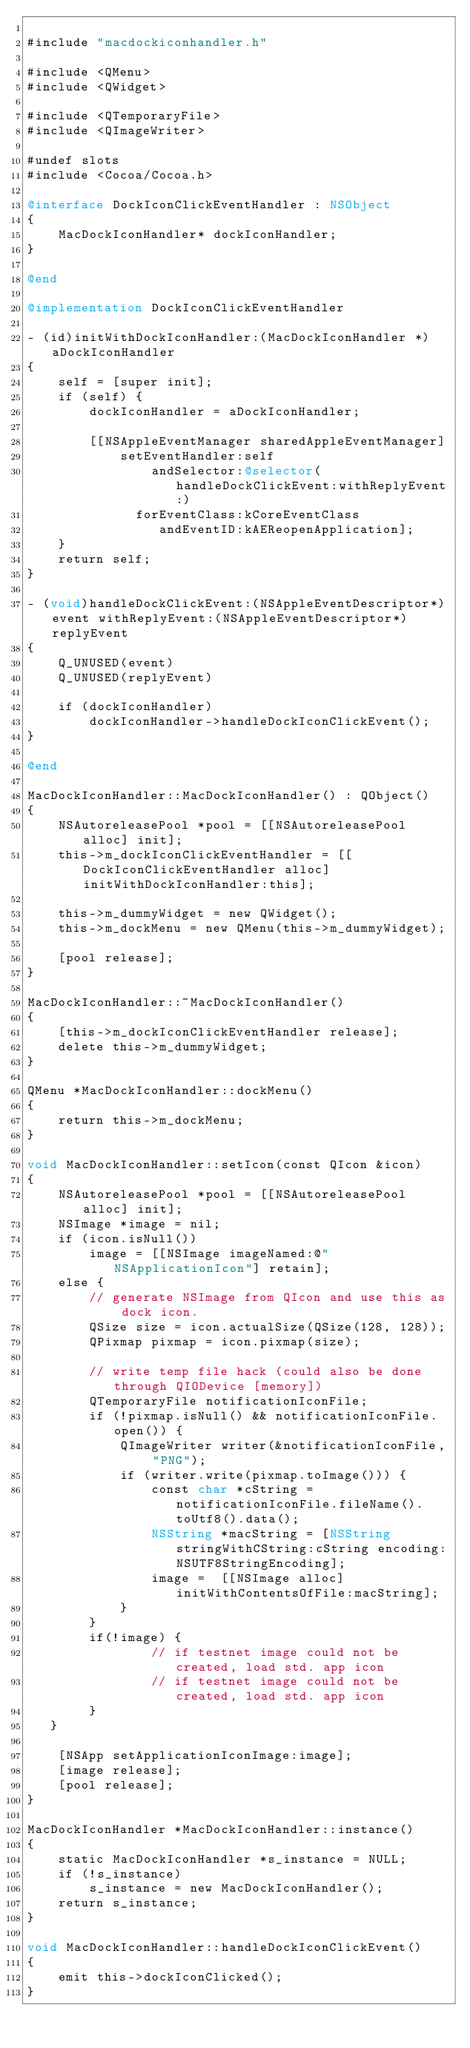Convert code to text. <code><loc_0><loc_0><loc_500><loc_500><_ObjectiveC_>
#include "macdockiconhandler.h"

#include <QMenu>
#include <QWidget>

#include <QTemporaryFile>
#include <QImageWriter>

#undef slots
#include <Cocoa/Cocoa.h>

@interface DockIconClickEventHandler : NSObject
{
    MacDockIconHandler* dockIconHandler;
}

@end

@implementation DockIconClickEventHandler

- (id)initWithDockIconHandler:(MacDockIconHandler *)aDockIconHandler
{
    self = [super init];
    if (self) {
        dockIconHandler = aDockIconHandler;

        [[NSAppleEventManager sharedAppleEventManager]
            setEventHandler:self
                andSelector:@selector(handleDockClickEvent:withReplyEvent:)
              forEventClass:kCoreEventClass
                 andEventID:kAEReopenApplication];
    }
    return self;
}

- (void)handleDockClickEvent:(NSAppleEventDescriptor*)event withReplyEvent:(NSAppleEventDescriptor*)replyEvent
{
    Q_UNUSED(event)
    Q_UNUSED(replyEvent)

    if (dockIconHandler)
        dockIconHandler->handleDockIconClickEvent();
}

@end

MacDockIconHandler::MacDockIconHandler() : QObject()
{
    NSAutoreleasePool *pool = [[NSAutoreleasePool alloc] init];
    this->m_dockIconClickEventHandler = [[DockIconClickEventHandler alloc] initWithDockIconHandler:this];

    this->m_dummyWidget = new QWidget();
    this->m_dockMenu = new QMenu(this->m_dummyWidget);
    
    [pool release];
}

MacDockIconHandler::~MacDockIconHandler()
{
    [this->m_dockIconClickEventHandler release];
    delete this->m_dummyWidget;
}

QMenu *MacDockIconHandler::dockMenu()
{
    return this->m_dockMenu;
}

void MacDockIconHandler::setIcon(const QIcon &icon)
{
    NSAutoreleasePool *pool = [[NSAutoreleasePool alloc] init];
    NSImage *image = nil;
    if (icon.isNull())
        image = [[NSImage imageNamed:@"NSApplicationIcon"] retain];
    else {
		// generate NSImage from QIcon and use this as dock icon.
        QSize size = icon.actualSize(QSize(128, 128));
        QPixmap pixmap = icon.pixmap(size);
        
		// write temp file hack (could also be done through QIODevice [memory])
		QTemporaryFile notificationIconFile;
		if (!pixmap.isNull() && notificationIconFile.open()) {
			QImageWriter writer(&notificationIconFile, "PNG");
			if (writer.write(pixmap.toImage())) {
				const char *cString = notificationIconFile.fileName().toUtf8().data();
				NSString *macString = [NSString stringWithCString:cString encoding:NSUTF8StringEncoding];
				image =  [[NSImage alloc] initWithContentsOfFile:macString];
			}
		}
		if(!image) {
				// if testnet image could not be created, load std. app icon
				// if testnet image could not be created, load std. app icon
		}
   }

    [NSApp setApplicationIconImage:image];
    [image release];
    [pool release];
}

MacDockIconHandler *MacDockIconHandler::instance()
{
    static MacDockIconHandler *s_instance = NULL;
    if (!s_instance)
        s_instance = new MacDockIconHandler();
    return s_instance;
}

void MacDockIconHandler::handleDockIconClickEvent()
{
    emit this->dockIconClicked();
}
</code> 